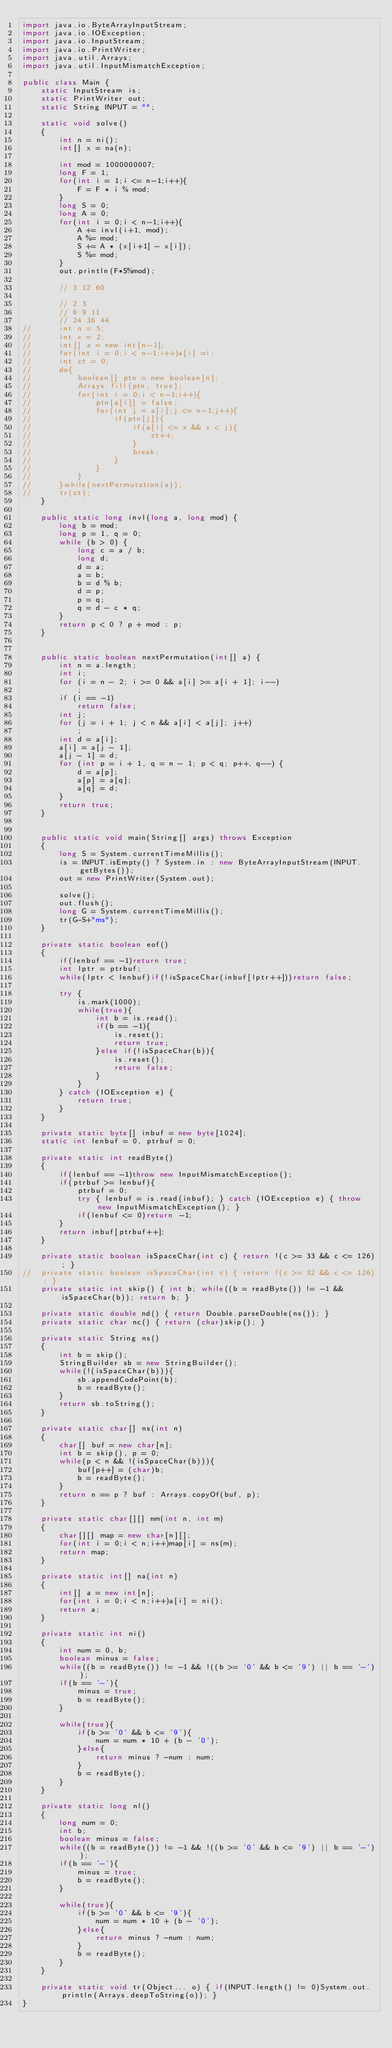<code> <loc_0><loc_0><loc_500><loc_500><_Java_>import java.io.ByteArrayInputStream;
import java.io.IOException;
import java.io.InputStream;
import java.io.PrintWriter;
import java.util.Arrays;
import java.util.InputMismatchException;

public class Main {
	static InputStream is;
	static PrintWriter out;
	static String INPUT = "";
	
	static void solve()
	{
		int n = ni();
		int[] x = na(n);
		
		int mod = 1000000007;
		long F = 1;
		for(int i = 1;i <= n-1;i++){
			F = F * i % mod;
		}
		long S = 0;
		long A = 0;
		for(int i = 0;i < n-1;i++){
			A += invl(i+1, mod);
			A %= mod;
			S += A * (x[i+1] - x[i]);
			S %= mod;
		}
		out.println(F*S%mod);
		
		// 3 12 60
		
		// 2 3 
		// 6 9 11
		// 24 36 44
//		int n = 5;
//		int x = 2;
//		int[] a = new int[n-1];
//		for(int i = 0;i < n-1;i++)a[i] =i;
//		int ct = 0;
//		do{
//			boolean[] ptn = new boolean[n];
//			Arrays.fill(ptn, true);
//			for(int i = 0;i < n-1;i++){
//				ptn[a[i]] = false;
//				for(int j = a[i];j <= n-1;j++){
//					if(ptn[j]){
//						if(a[i] <= x && x < j){
//							ct++;
//						}
//						break;
//					}
//				}
//			}
//		}while(nextPermutation(a));
//		tr(ct);
	}
	
	public static long invl(long a, long mod) {
		long b = mod;
		long p = 1, q = 0;
		while (b > 0) {
			long c = a / b;
			long d;
			d = a;
			a = b;
			b = d % b;
			d = p;
			p = q;
			q = d - c * q;
		}
		return p < 0 ? p + mod : p;
	}

	
	public static boolean nextPermutation(int[] a) {
		int n = a.length;
		int i;
		for (i = n - 2; i >= 0 && a[i] >= a[i + 1]; i--)
			;
		if (i == -1)
			return false;
		int j;
		for (j = i + 1; j < n && a[i] < a[j]; j++)
			;
		int d = a[i];
		a[i] = a[j - 1];
		a[j - 1] = d;
		for (int p = i + 1, q = n - 1; p < q; p++, q--) {
			d = a[p];
			a[p] = a[q];
			a[q] = d;
		}
		return true;
	}

	
	public static void main(String[] args) throws Exception
	{
		long S = System.currentTimeMillis();
		is = INPUT.isEmpty() ? System.in : new ByteArrayInputStream(INPUT.getBytes());
		out = new PrintWriter(System.out);
		
		solve();
		out.flush();
		long G = System.currentTimeMillis();
		tr(G-S+"ms");
	}
	
	private static boolean eof()
	{
		if(lenbuf == -1)return true;
		int lptr = ptrbuf;
		while(lptr < lenbuf)if(!isSpaceChar(inbuf[lptr++]))return false;
		
		try {
			is.mark(1000);
			while(true){
				int b = is.read();
				if(b == -1){
					is.reset();
					return true;
				}else if(!isSpaceChar(b)){
					is.reset();
					return false;
				}
			}
		} catch (IOException e) {
			return true;
		}
	}
	
	private static byte[] inbuf = new byte[1024];
	static int lenbuf = 0, ptrbuf = 0;
	
	private static int readByte()
	{
		if(lenbuf == -1)throw new InputMismatchException();
		if(ptrbuf >= lenbuf){
			ptrbuf = 0;
			try { lenbuf = is.read(inbuf); } catch (IOException e) { throw new InputMismatchException(); }
			if(lenbuf <= 0)return -1;
		}
		return inbuf[ptrbuf++];
	}
	
	private static boolean isSpaceChar(int c) { return !(c >= 33 && c <= 126); }
//	private static boolean isSpaceChar(int c) { return !(c >= 32 && c <= 126); }
	private static int skip() { int b; while((b = readByte()) != -1 && isSpaceChar(b)); return b; }
	
	private static double nd() { return Double.parseDouble(ns()); }
	private static char nc() { return (char)skip(); }
	
	private static String ns()
	{
		int b = skip();
		StringBuilder sb = new StringBuilder();
		while(!(isSpaceChar(b))){
			sb.appendCodePoint(b);
			b = readByte();
		}
		return sb.toString();
	}
	
	private static char[] ns(int n)
	{
		char[] buf = new char[n];
		int b = skip(), p = 0;
		while(p < n && !(isSpaceChar(b))){
			buf[p++] = (char)b;
			b = readByte();
		}
		return n == p ? buf : Arrays.copyOf(buf, p);
	}
	
	private static char[][] nm(int n, int m)
	{
		char[][] map = new char[n][];
		for(int i = 0;i < n;i++)map[i] = ns(m);
		return map;
	}
	
	private static int[] na(int n)
	{
		int[] a = new int[n];
		for(int i = 0;i < n;i++)a[i] = ni();
		return a;
	}
	
	private static int ni()
	{
		int num = 0, b;
		boolean minus = false;
		while((b = readByte()) != -1 && !((b >= '0' && b <= '9') || b == '-'));
		if(b == '-'){
			minus = true;
			b = readByte();
		}
		
		while(true){
			if(b >= '0' && b <= '9'){
				num = num * 10 + (b - '0');
			}else{
				return minus ? -num : num;
			}
			b = readByte();
		}
	}
	
	private static long nl()
	{
		long num = 0;
		int b;
		boolean minus = false;
		while((b = readByte()) != -1 && !((b >= '0' && b <= '9') || b == '-'));
		if(b == '-'){
			minus = true;
			b = readByte();
		}
		
		while(true){
			if(b >= '0' && b <= '9'){
				num = num * 10 + (b - '0');
			}else{
				return minus ? -num : num;
			}
			b = readByte();
		}
	}
	
	private static void tr(Object... o) { if(INPUT.length() != 0)System.out.println(Arrays.deepToString(o)); }
}
</code> 